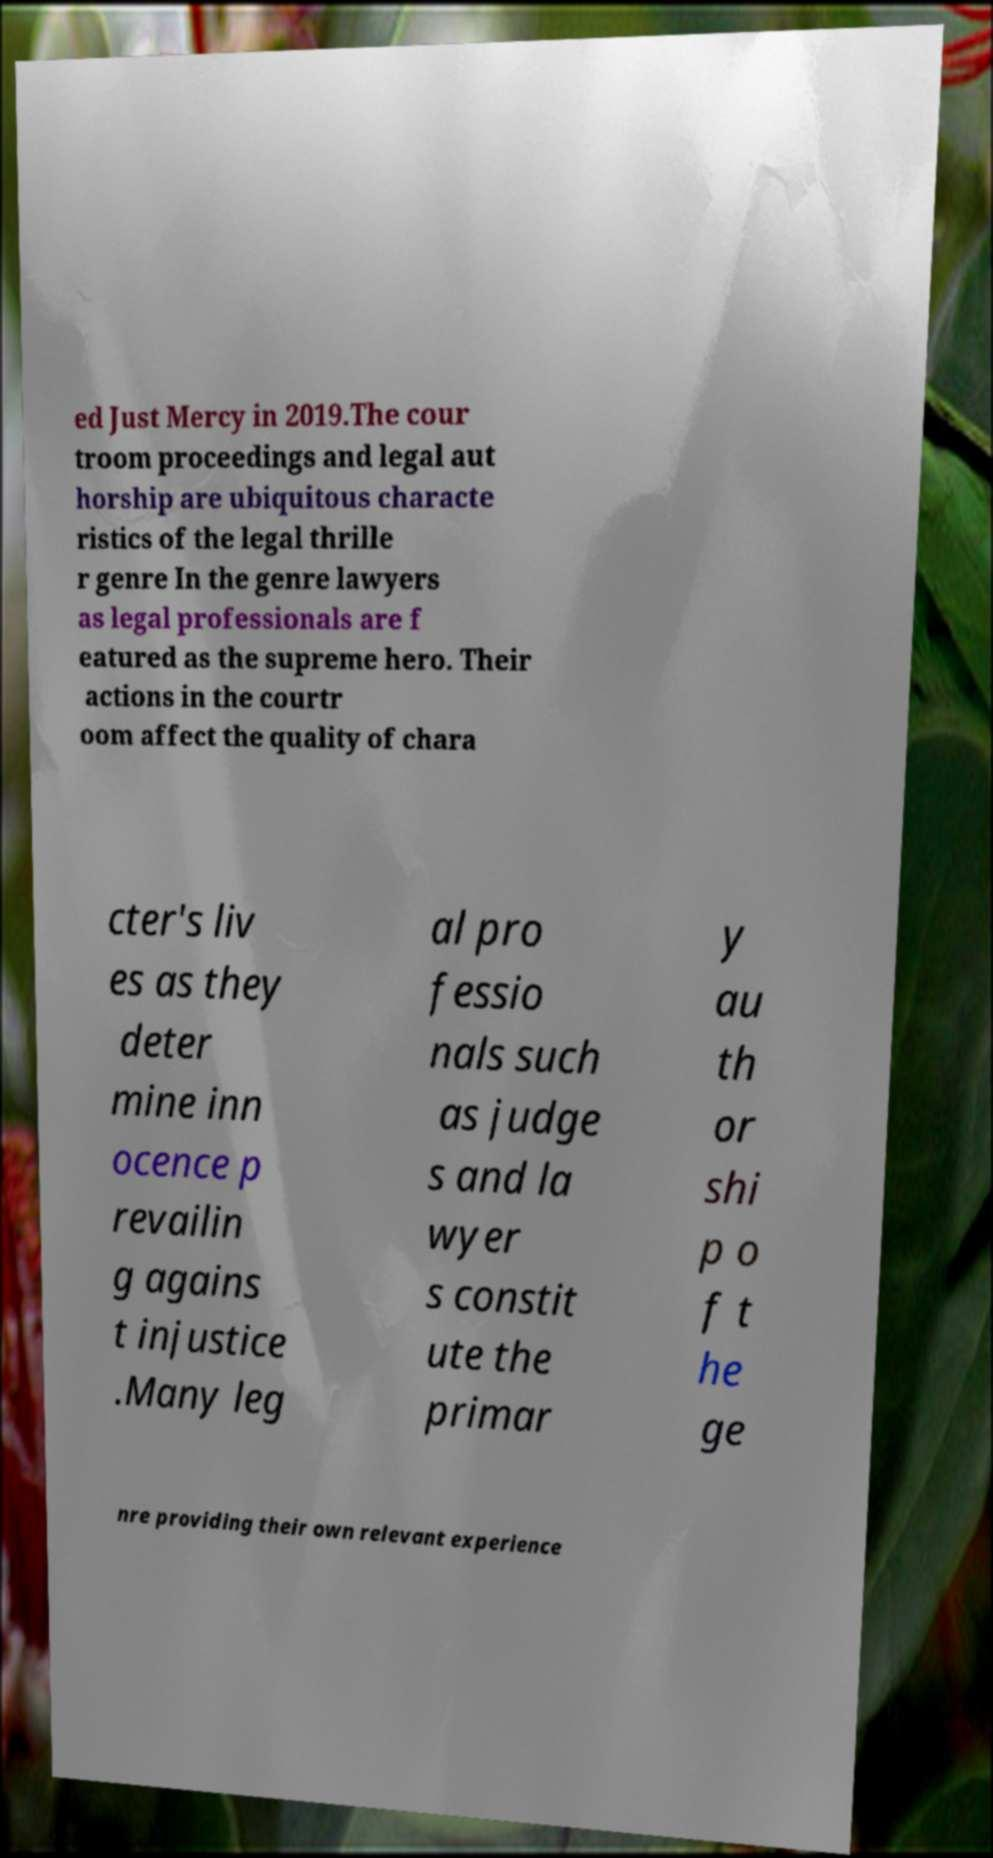I need the written content from this picture converted into text. Can you do that? ed Just Mercy in 2019.The cour troom proceedings and legal aut horship are ubiquitous characte ristics of the legal thrille r genre In the genre lawyers as legal professionals are f eatured as the supreme hero. Their actions in the courtr oom affect the quality of chara cter's liv es as they deter mine inn ocence p revailin g agains t injustice .Many leg al pro fessio nals such as judge s and la wyer s constit ute the primar y au th or shi p o f t he ge nre providing their own relevant experience 